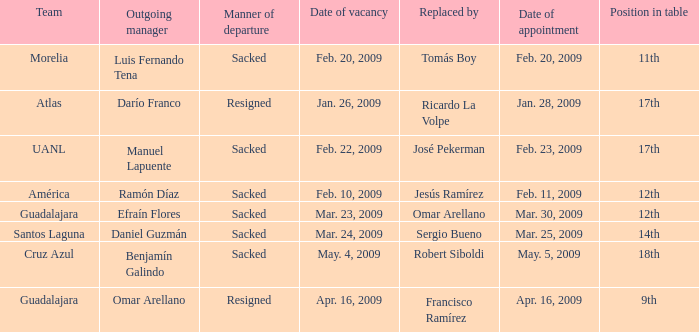What is Position in Table, when Replaced By is "Sergio Bueno"? 14th. Write the full table. {'header': ['Team', 'Outgoing manager', 'Manner of departure', 'Date of vacancy', 'Replaced by', 'Date of appointment', 'Position in table'], 'rows': [['Morelia', 'Luis Fernando Tena', 'Sacked', 'Feb. 20, 2009', 'Tomás Boy', 'Feb. 20, 2009', '11th'], ['Atlas', 'Darío Franco', 'Resigned', 'Jan. 26, 2009', 'Ricardo La Volpe', 'Jan. 28, 2009', '17th'], ['UANL', 'Manuel Lapuente', 'Sacked', 'Feb. 22, 2009', 'José Pekerman', 'Feb. 23, 2009', '17th'], ['América', 'Ramón Díaz', 'Sacked', 'Feb. 10, 2009', 'Jesús Ramírez', 'Feb. 11, 2009', '12th'], ['Guadalajara', 'Efraín Flores', 'Sacked', 'Mar. 23, 2009', 'Omar Arellano', 'Mar. 30, 2009', '12th'], ['Santos Laguna', 'Daniel Guzmán', 'Sacked', 'Mar. 24, 2009', 'Sergio Bueno', 'Mar. 25, 2009', '14th'], ['Cruz Azul', 'Benjamín Galindo', 'Sacked', 'May. 4, 2009', 'Robert Siboldi', 'May. 5, 2009', '18th'], ['Guadalajara', 'Omar Arellano', 'Resigned', 'Apr. 16, 2009', 'Francisco Ramírez', 'Apr. 16, 2009', '9th']]} 